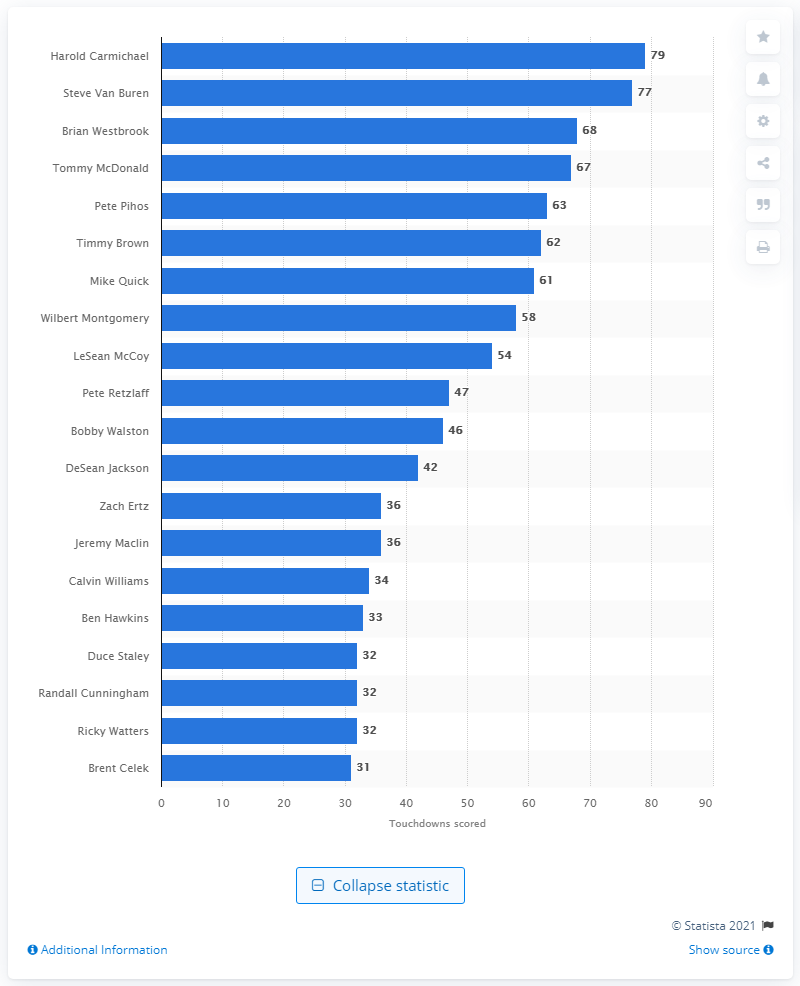Point out several critical features in this image. Harold Carmichael is the career touchdown leader of the Philadelphia Eagles. 